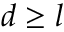<formula> <loc_0><loc_0><loc_500><loc_500>d \geq l</formula> 